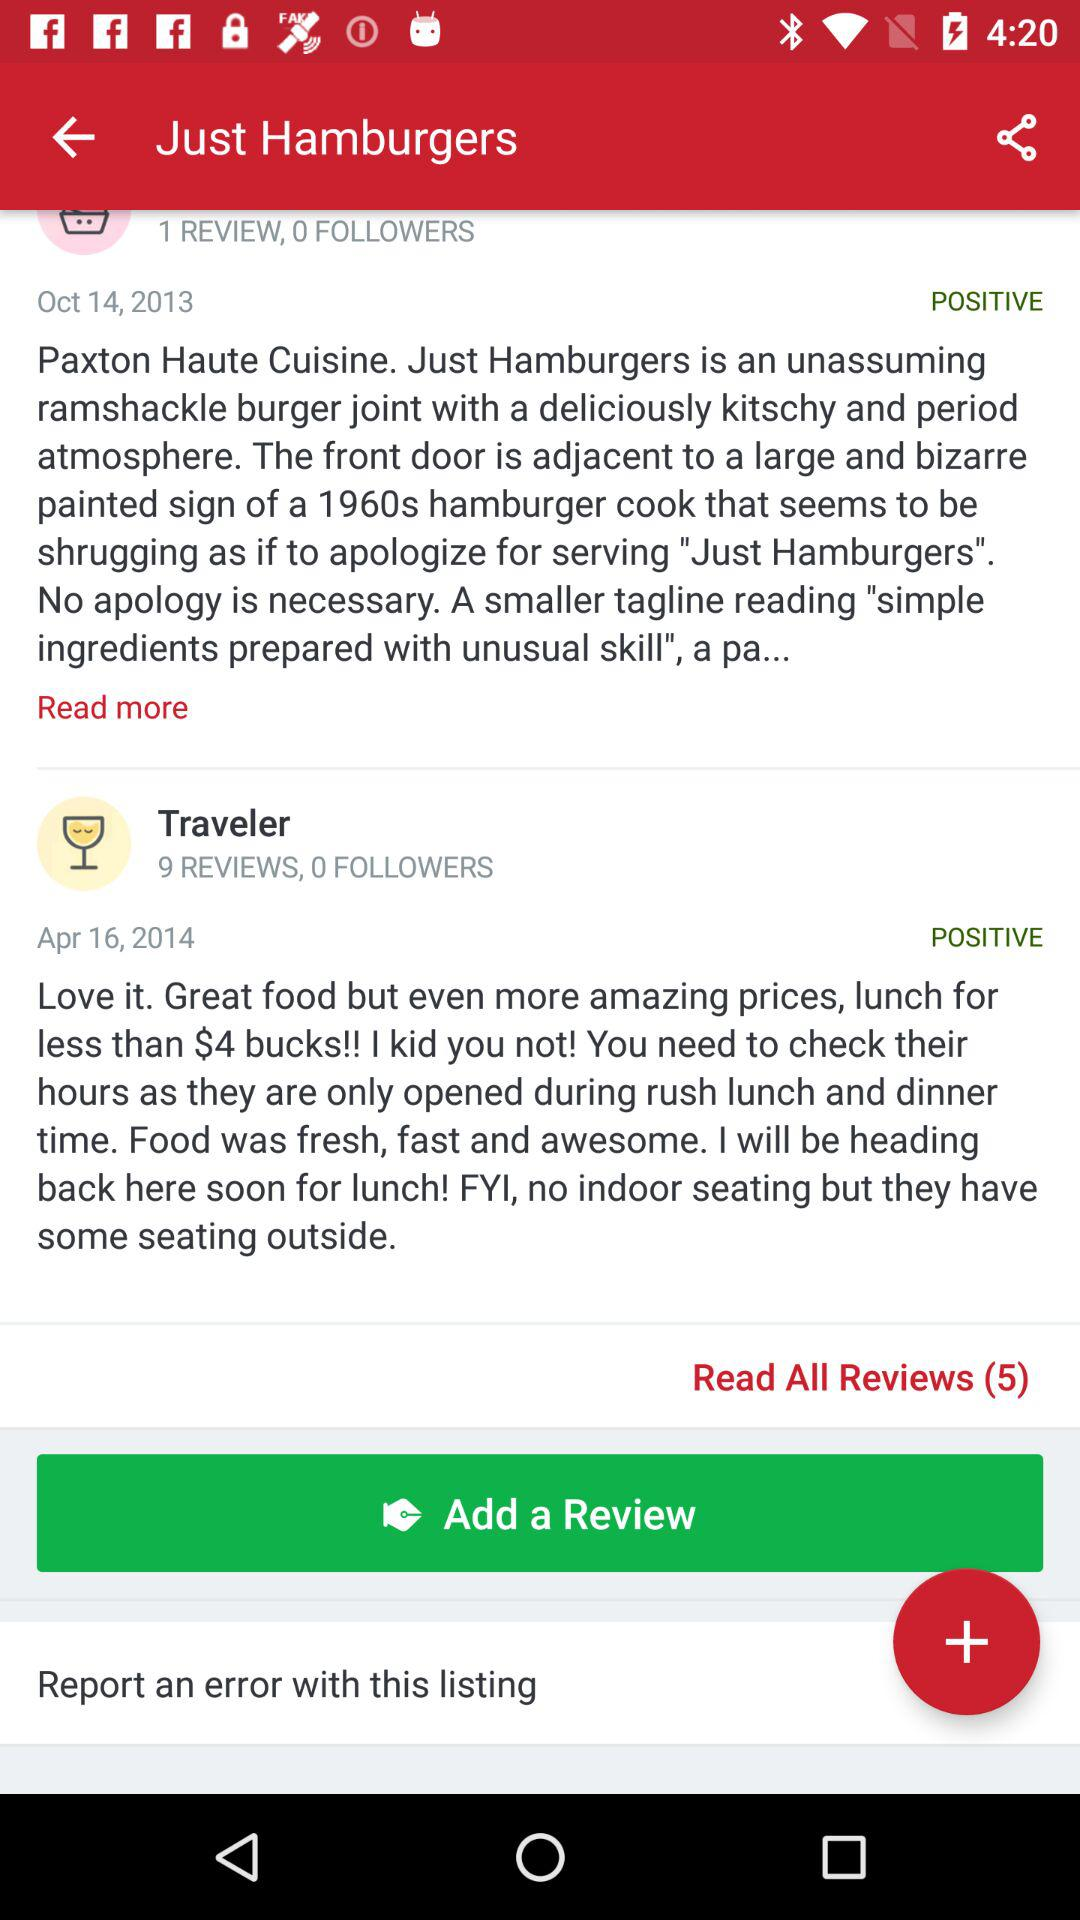How many reviews are positive for Just Hamburgers?
Answer the question using a single word or phrase. 2 